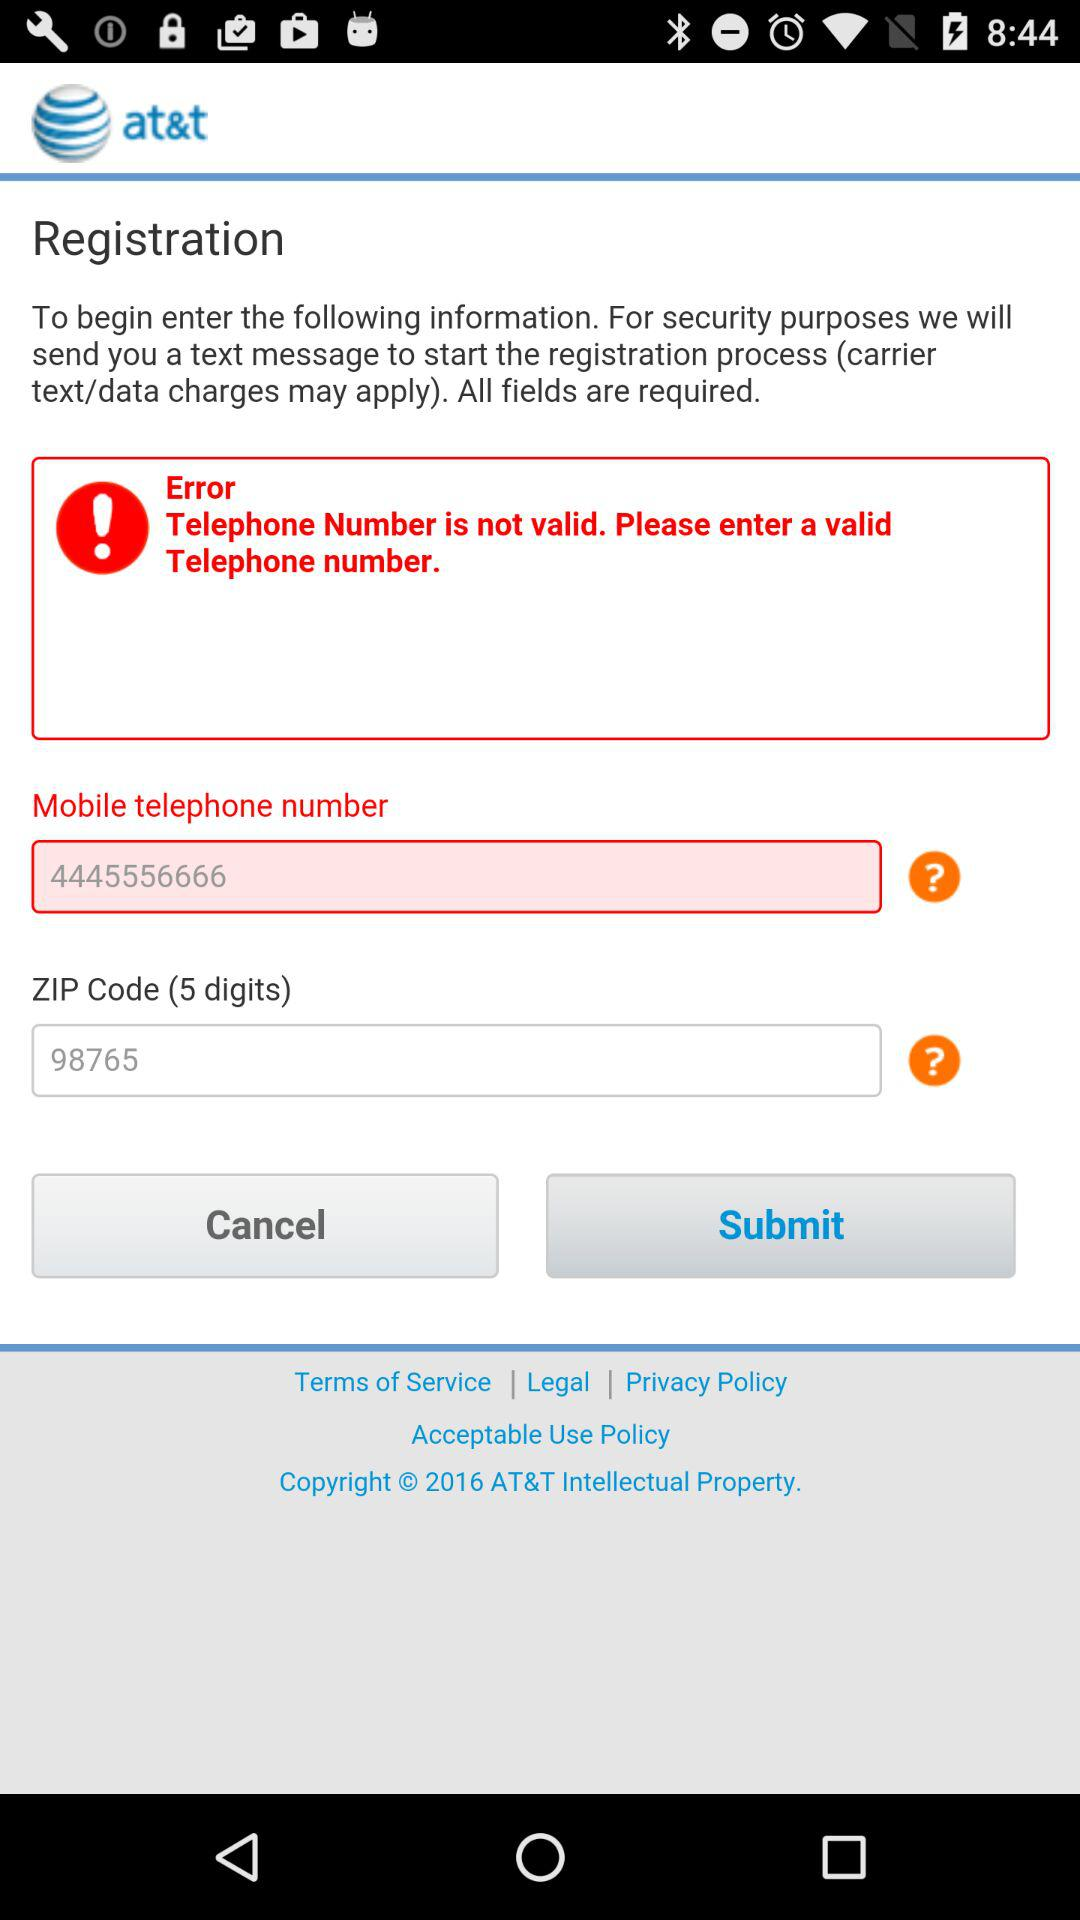What is the application name? The application name is "at&t". 